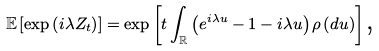<formula> <loc_0><loc_0><loc_500><loc_500>\mathbb { E } \left [ \exp \left ( i \lambda Z _ { t } \right ) \right ] = \exp \left [ t \int _ { \mathbb { R } } \left ( e ^ { i \lambda u } - 1 - i \lambda u \right ) \rho \left ( d u \right ) \right ] \text {,}</formula> 